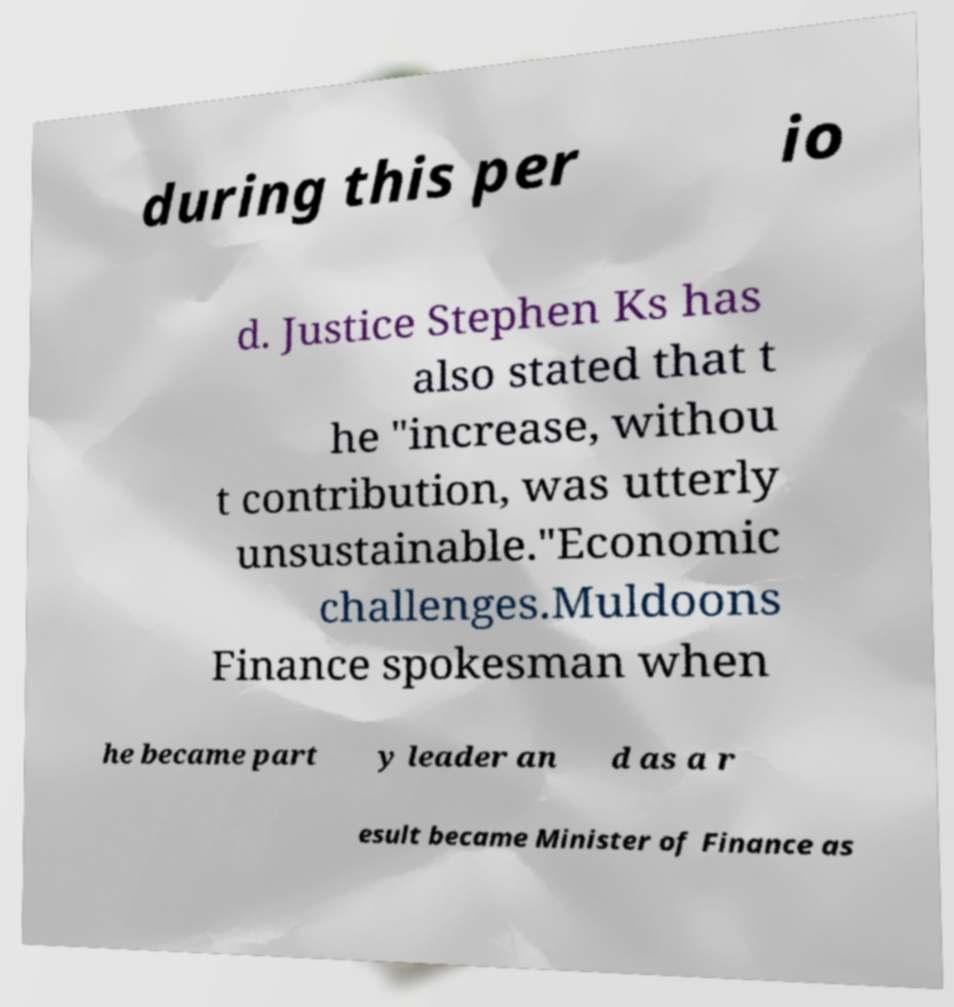Could you assist in decoding the text presented in this image and type it out clearly? during this per io d. Justice Stephen Ks has also stated that t he "increase, withou t contribution, was utterly unsustainable."Economic challenges.Muldoons Finance spokesman when he became part y leader an d as a r esult became Minister of Finance as 